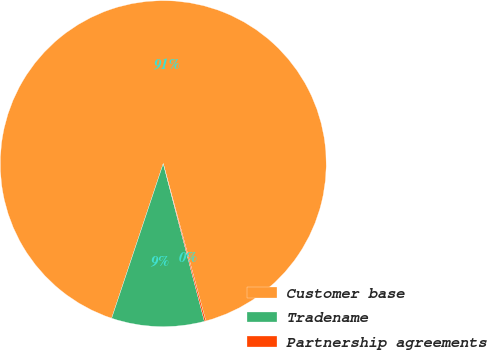<chart> <loc_0><loc_0><loc_500><loc_500><pie_chart><fcel>Customer base<fcel>Tradename<fcel>Partnership agreements<nl><fcel>90.67%<fcel>9.19%<fcel>0.14%<nl></chart> 